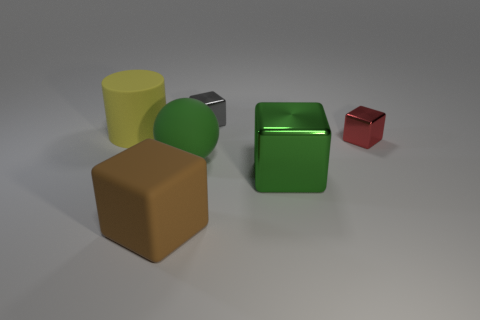Are there an equal number of small objects behind the brown rubber object and tiny metallic objects?
Your response must be concise. Yes. How many objects are green matte things or blocks that are right of the small gray object?
Offer a very short reply. 3. Is the color of the sphere the same as the large metal thing?
Offer a terse response. Yes. Is there a tiny red block that has the same material as the large brown thing?
Your response must be concise. No. What color is the rubber object that is the same shape as the big shiny thing?
Offer a very short reply. Brown. Are the yellow cylinder and the green object that is right of the green matte sphere made of the same material?
Offer a very short reply. No. What is the shape of the small object in front of the thing to the left of the big brown thing?
Offer a very short reply. Cube. Is the size of the metal object that is behind the yellow thing the same as the big brown block?
Provide a short and direct response. No. How many other things are the same shape as the big green rubber object?
Your answer should be compact. 0. There is a metallic cube in front of the tiny red metallic object; is it the same color as the big rubber ball?
Make the answer very short. Yes. 